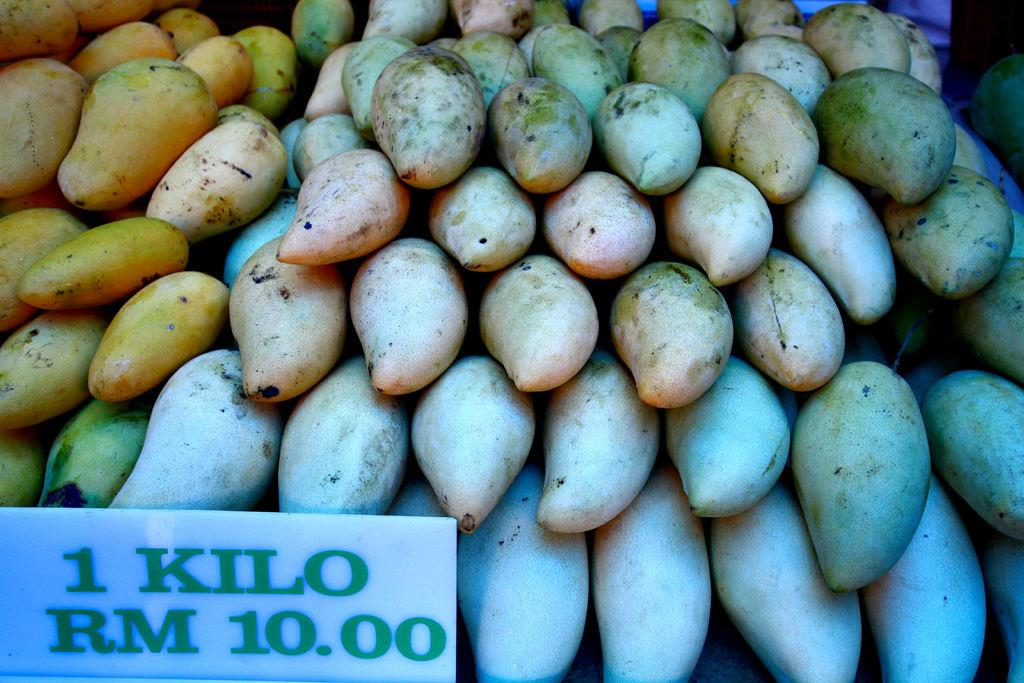What type of objects are in the image? There is a group of fruits in the image. How are the fruits arranged in the image? The fruits are placed one above another. What else can be seen in the image besides the fruits? There is a signboard in the image. What information is provided on the signboard? The signboard has text on it. What type of fiction is the partner involved in, as seen in the image? There is no fiction or partner present in the image; it features a group of fruits and a signboard with text. 